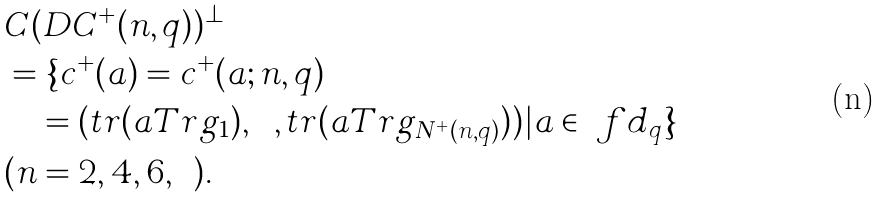<formula> <loc_0><loc_0><loc_500><loc_500>& C ( D C ^ { + } ( n , q ) ) ^ { \bot } \\ & = \{ c ^ { + } ( a ) = c ^ { + } ( a ; n , q ) \\ & \quad = ( t r ( a T r g _ { 1 } ) , \cdots , t r ( a T r g _ { N ^ { + } ( n , q ) } ) ) | a \in \ f d _ { q } \} \\ & ( n = 2 , 4 , 6 , \cdots ) .</formula> 